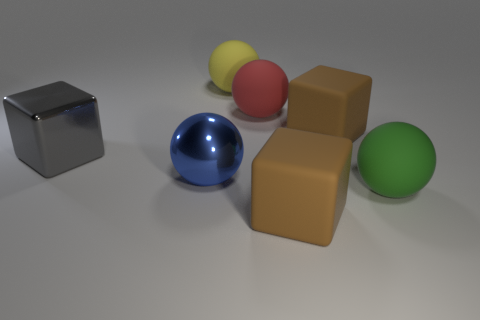How many objects are there in the image, and can you categorize them based on their shape? In the image, there are seven objects in total. They can be categorized into two shapes: four spheres and three cubes. The spheres are blue, red, yellow, and green. The cubes are silver and brown, with two of them in brown. 